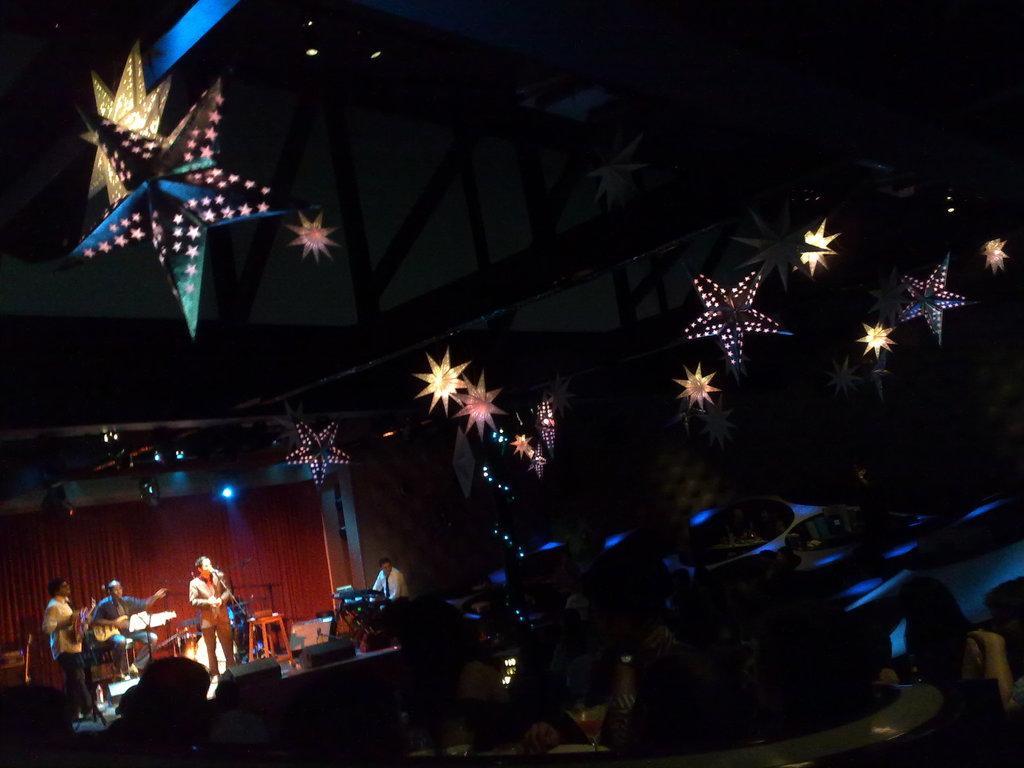Please provide a concise description of this image. In the picture we can see a hall with a stage on it, we can see some people are giving musical performance and behind them, we can see a red color curtain and in front of them, we can see some people are sitting and on the chairs near the tables and to the ceiling of the hall we can see stars are decorated and to the ceiling of the stage we can see some lights. 